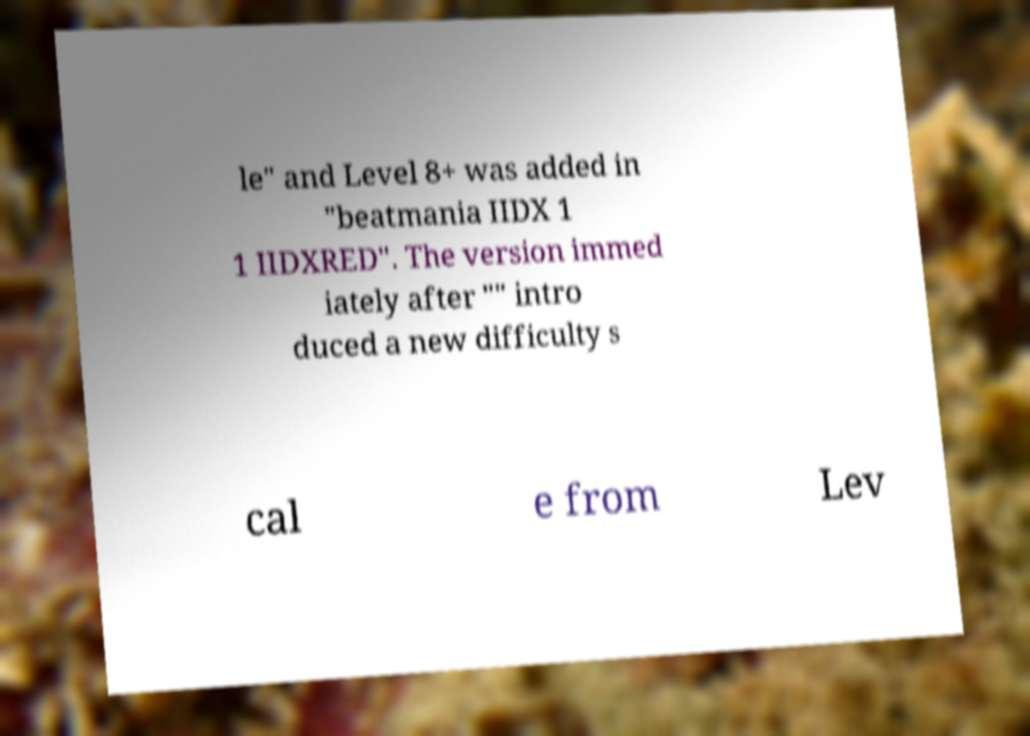Could you extract and type out the text from this image? le" and Level 8+ was added in "beatmania IIDX 1 1 IIDXRED". The version immed iately after "" intro duced a new difficulty s cal e from Lev 